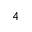<formula> <loc_0><loc_0><loc_500><loc_500>_ { 4 }</formula> 